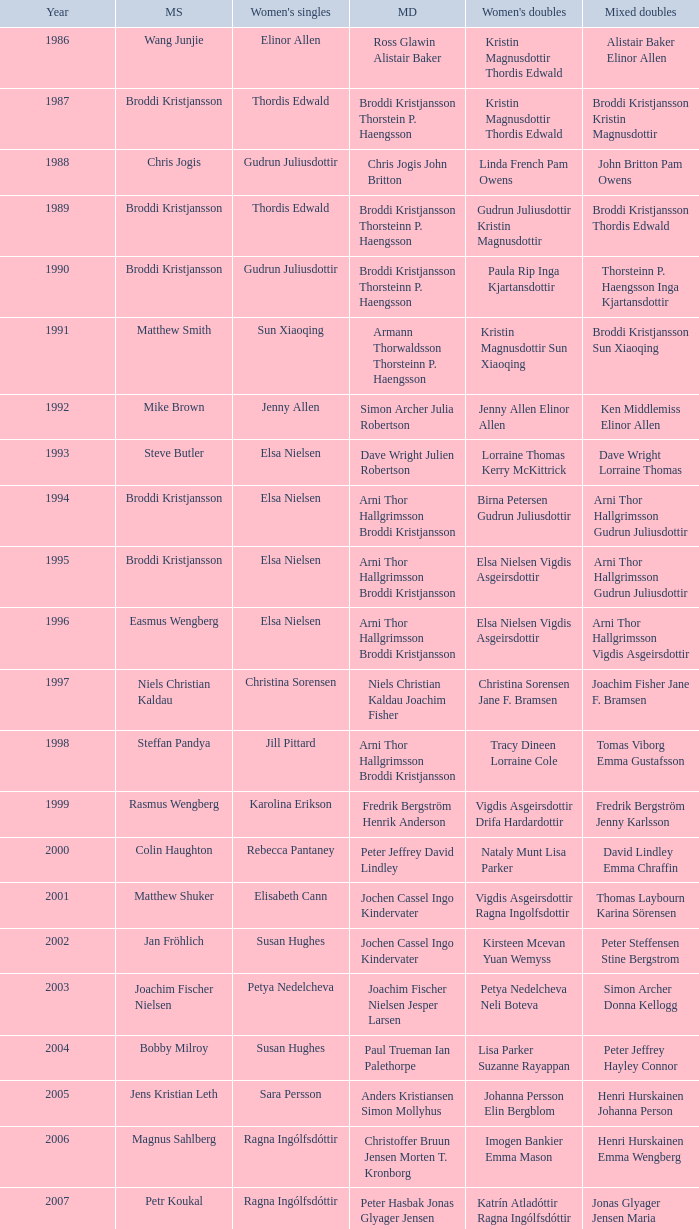In which women's doubles did Wang Junjie play men's singles? Kristin Magnusdottir Thordis Edwald. 